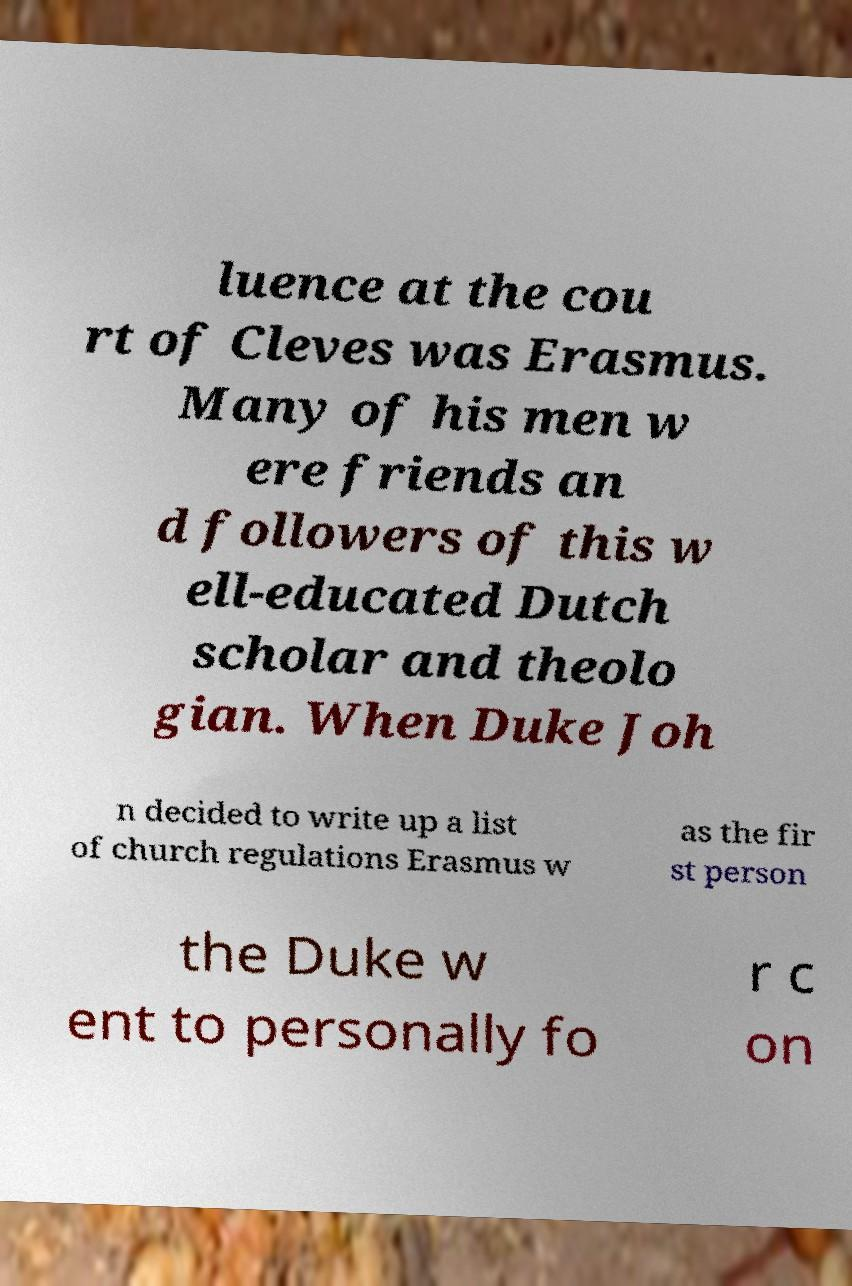Can you accurately transcribe the text from the provided image for me? luence at the cou rt of Cleves was Erasmus. Many of his men w ere friends an d followers of this w ell-educated Dutch scholar and theolo gian. When Duke Joh n decided to write up a list of church regulations Erasmus w as the fir st person the Duke w ent to personally fo r c on 